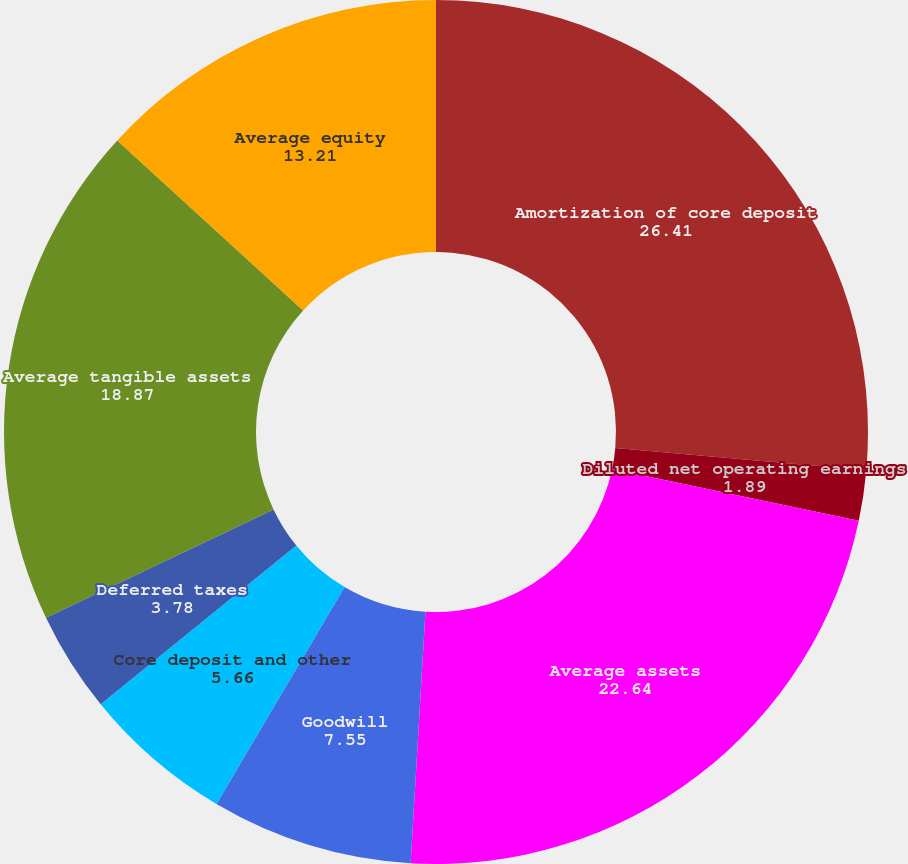Convert chart. <chart><loc_0><loc_0><loc_500><loc_500><pie_chart><fcel>Amortization of core deposit<fcel>Diluted earnings per common<fcel>Diluted net operating earnings<fcel>Average assets<fcel>Goodwill<fcel>Core deposit and other<fcel>Deferred taxes<fcel>Average tangible assets<fcel>Average equity<nl><fcel>26.41%<fcel>0.0%<fcel>1.89%<fcel>22.64%<fcel>7.55%<fcel>5.66%<fcel>3.78%<fcel>18.87%<fcel>13.21%<nl></chart> 